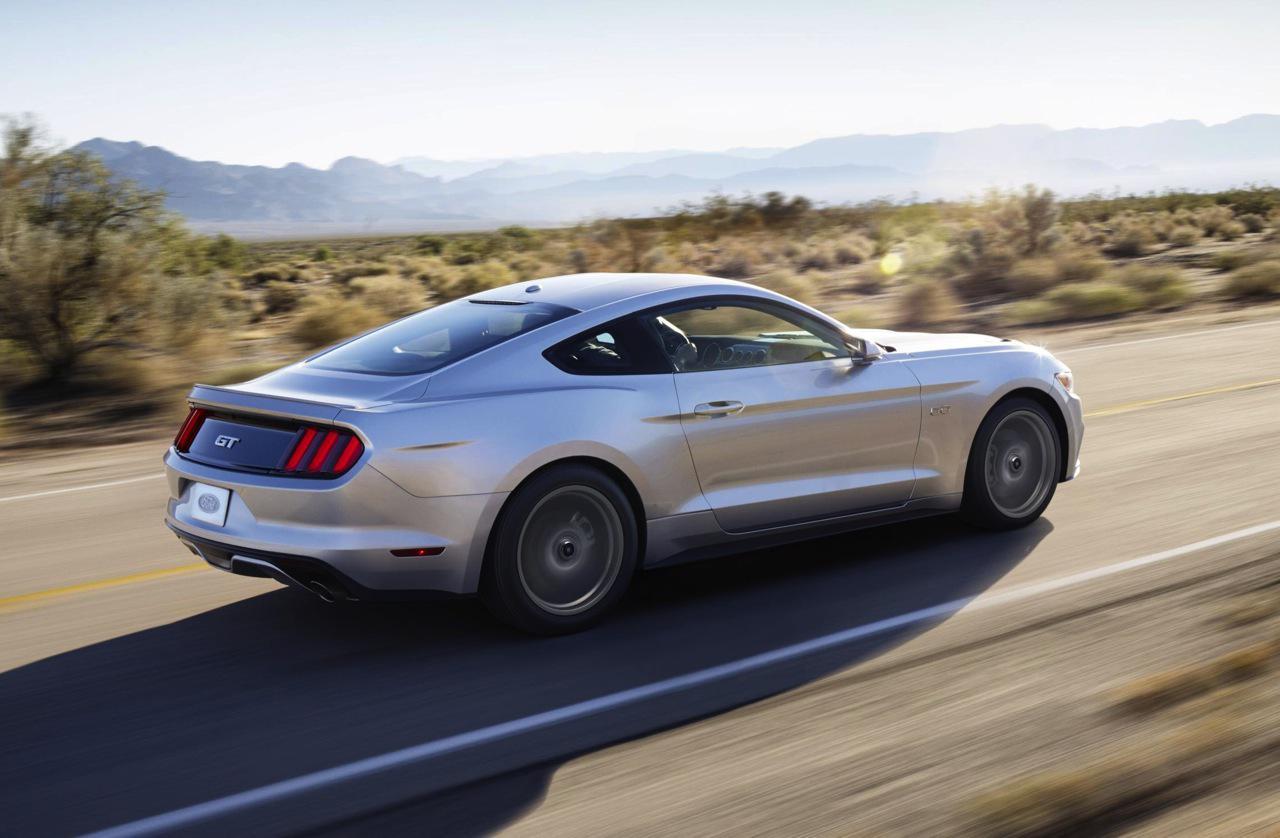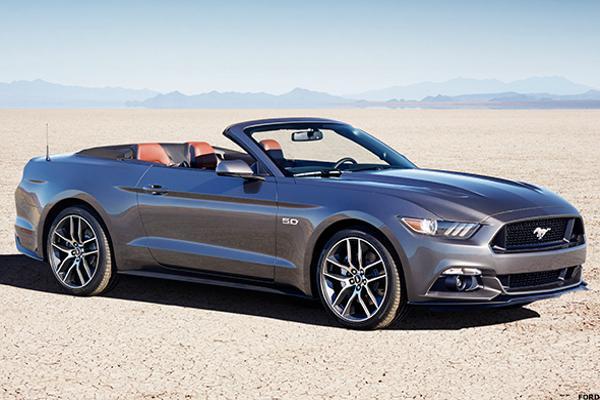The first image is the image on the left, the second image is the image on the right. Evaluate the accuracy of this statement regarding the images: "A red convertible with the top down is shown in the left image on a paved surface". Is it true? Answer yes or no. No. The first image is the image on the left, the second image is the image on the right. For the images displayed, is the sentence "A red convertible is displayed at an angle on pavement in the left image, while the right image shows a white convertible." factually correct? Answer yes or no. No. 